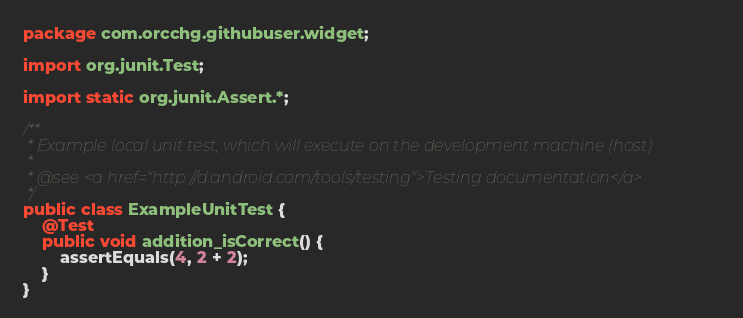<code> <loc_0><loc_0><loc_500><loc_500><_Java_>package com.orcchg.githubuser.widget;

import org.junit.Test;

import static org.junit.Assert.*;

/**
 * Example local unit test, which will execute on the development machine (host).
 *
 * @see <a href="http://d.android.com/tools/testing">Testing documentation</a>
 */
public class ExampleUnitTest {
    @Test
    public void addition_isCorrect() {
        assertEquals(4, 2 + 2);
    }
}</code> 